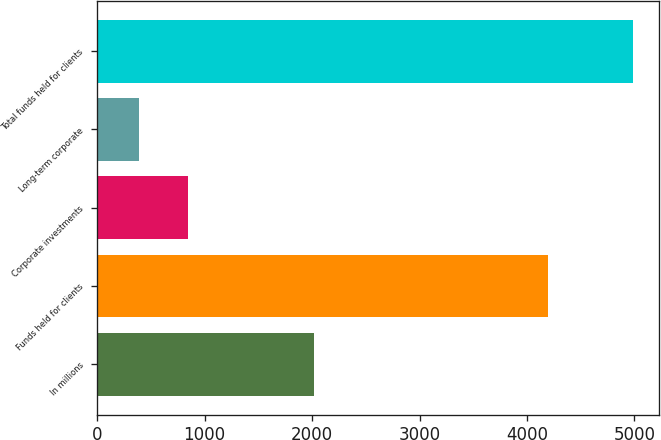Convert chart to OTSL. <chart><loc_0><loc_0><loc_500><loc_500><bar_chart><fcel>In millions<fcel>Funds held for clients<fcel>Corporate investments<fcel>Long-term corporate<fcel>Total funds held for clients<nl><fcel>2014<fcel>4198.6<fcel>845.33<fcel>385.6<fcel>4982.9<nl></chart> 